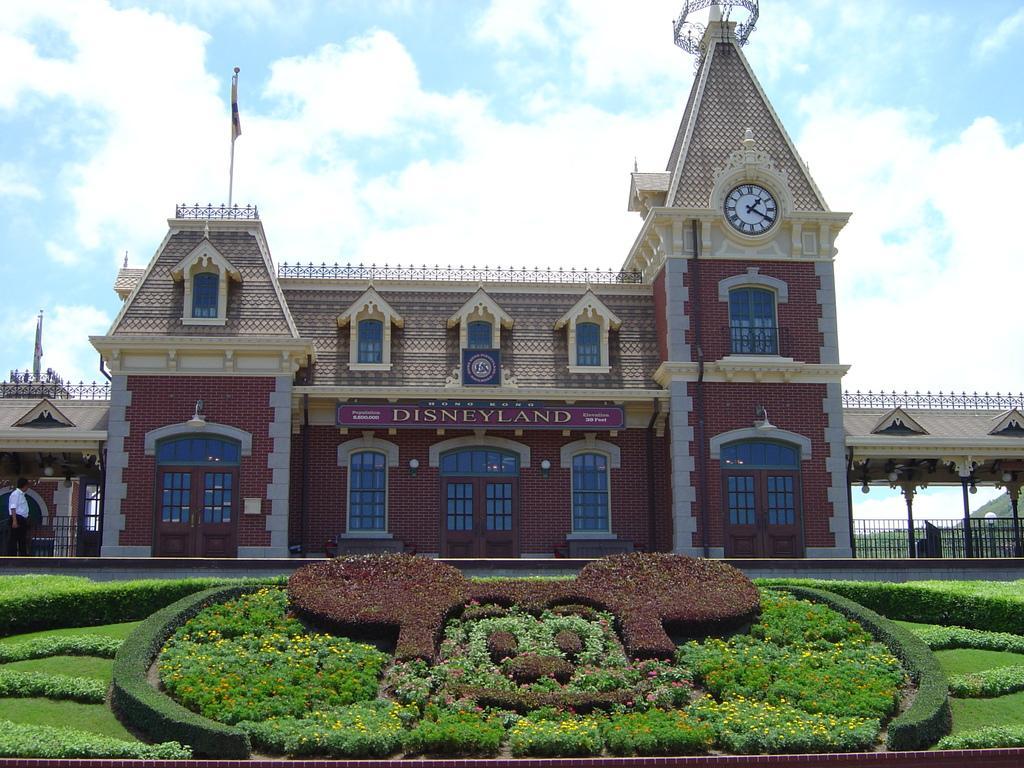Describe this image in one or two sentences. In this picture we can observe a building which is in brown and green color. We can observe a white color clock on the wall of the building. There are some plants in this picture. We can observe brown and green color plants. In the background there is a sky with some clouds. 